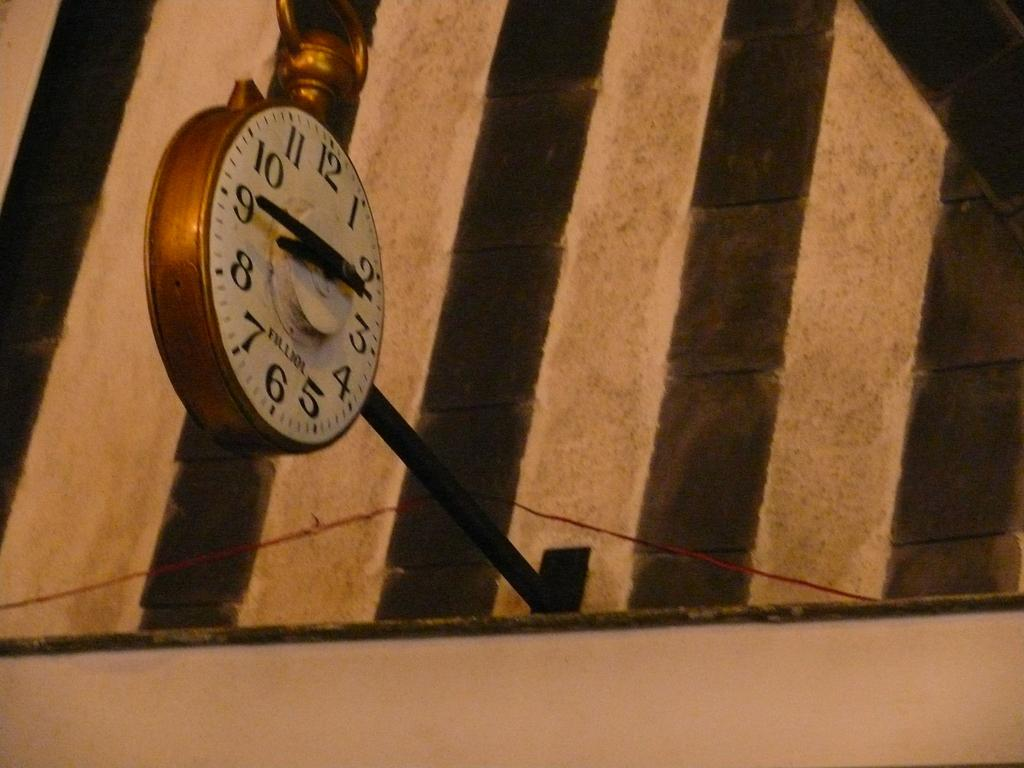<image>
Write a terse but informative summary of the picture. A clock attached to the striped wall shows a time of 8:45. 